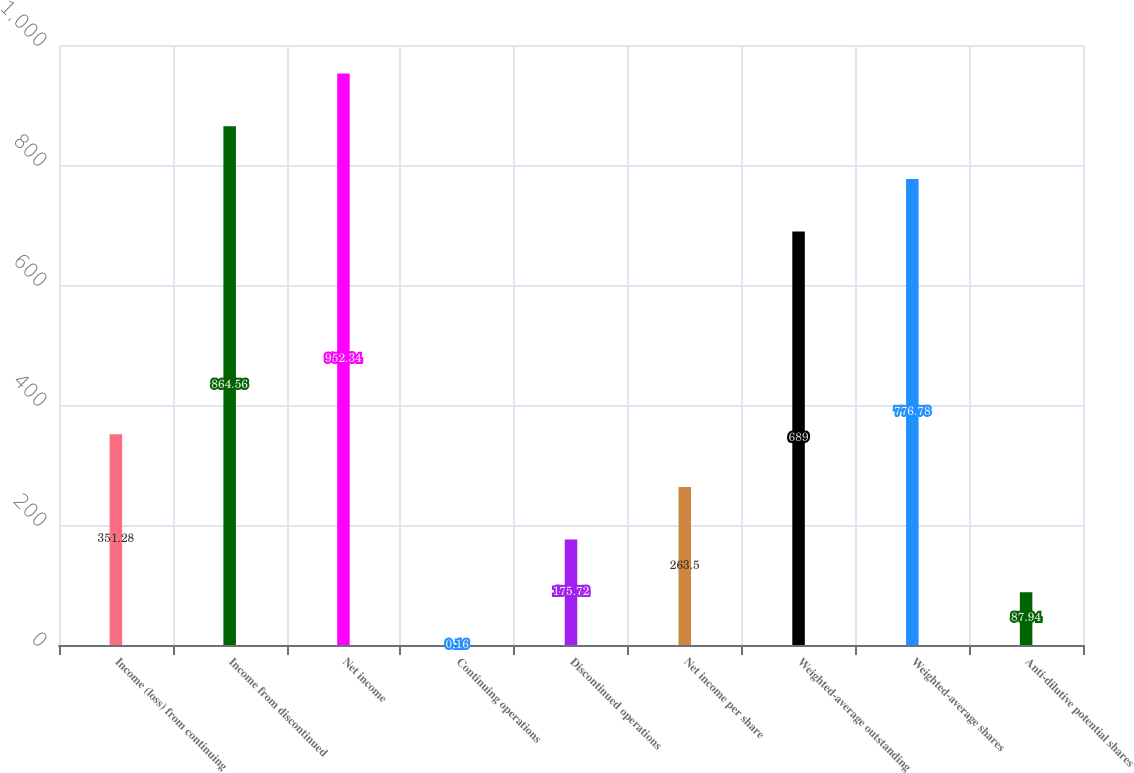Convert chart. <chart><loc_0><loc_0><loc_500><loc_500><bar_chart><fcel>Income (loss) from continuing<fcel>Income from discontinued<fcel>Net income<fcel>Continuing operations<fcel>Discontinued operations<fcel>Net income per share<fcel>Weighted-average outstanding<fcel>Weighted-average shares<fcel>Anti-dilutive potential shares<nl><fcel>351.28<fcel>864.56<fcel>952.34<fcel>0.16<fcel>175.72<fcel>263.5<fcel>689<fcel>776.78<fcel>87.94<nl></chart> 